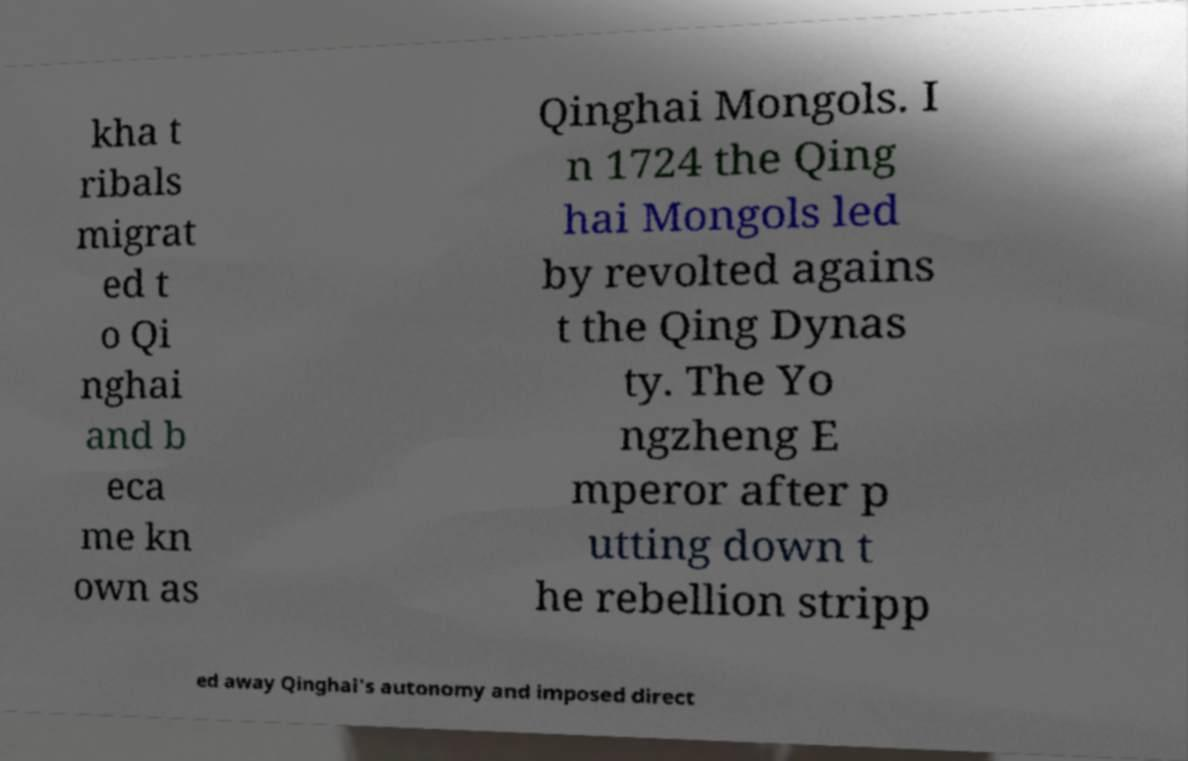What messages or text are displayed in this image? I need them in a readable, typed format. kha t ribals migrat ed t o Qi nghai and b eca me kn own as Qinghai Mongols. I n 1724 the Qing hai Mongols led by revolted agains t the Qing Dynas ty. The Yo ngzheng E mperor after p utting down t he rebellion stripp ed away Qinghai's autonomy and imposed direct 